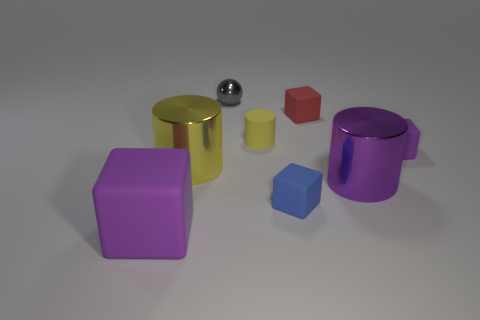What number of other objects are there of the same color as the small matte cylinder?
Your response must be concise. 1. Is the small yellow object the same shape as the large rubber thing?
Give a very brief answer. No. What is the material of the large thing that is both behind the big purple cube and on the left side of the tiny blue object?
Your answer should be very brief. Metal. How many large purple metallic things have the same shape as the small yellow thing?
Offer a terse response. 1. There is a purple matte cube that is behind the metallic cylinder that is left of the tiny matte block that is left of the tiny red block; what size is it?
Ensure brevity in your answer.  Small. Is the number of gray metal balls that are in front of the big rubber block greater than the number of tiny blue matte blocks?
Make the answer very short. No. Is there a matte cylinder?
Your response must be concise. Yes. What number of yellow rubber objects are the same size as the blue object?
Keep it short and to the point. 1. Are there more things that are to the right of the blue matte object than small things in front of the gray shiny sphere?
Offer a terse response. No. There is a red cube that is the same size as the blue block; what material is it?
Offer a very short reply. Rubber. 